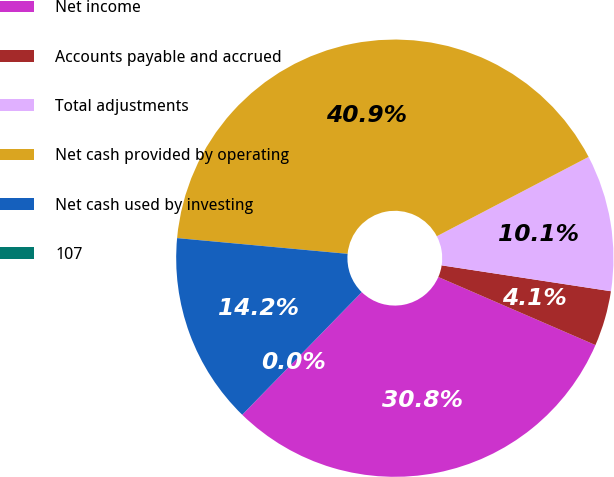Convert chart to OTSL. <chart><loc_0><loc_0><loc_500><loc_500><pie_chart><fcel>Net income<fcel>Accounts payable and accrued<fcel>Total adjustments<fcel>Net cash provided by operating<fcel>Net cash used by investing<fcel>107<nl><fcel>30.79%<fcel>4.09%<fcel>10.08%<fcel>40.87%<fcel>14.17%<fcel>0.0%<nl></chart> 